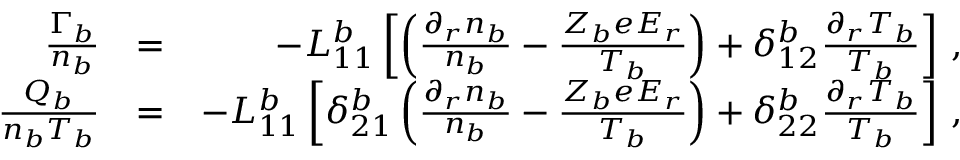<formula> <loc_0><loc_0><loc_500><loc_500>\begin{array} { r l r } { \frac { \Gamma _ { b } } { n _ { b } } } & { = } & { - L _ { 1 1 } ^ { b } \left [ \left ( \frac { \partial _ { r } n _ { b } } { n _ { b } } - \frac { Z _ { b } e E _ { r } } { T _ { b } } \right ) + \delta _ { 1 2 } ^ { b } \frac { \partial _ { r } T _ { b } } { T _ { b } } \right ] \, , } \\ { \frac { Q _ { b } } { n _ { b } T _ { b } } } & { = } & { - L _ { 1 1 } ^ { b } \left [ \delta _ { 2 1 } ^ { b } \left ( \frac { \partial _ { r } n _ { b } } { n _ { b } } - \frac { Z _ { b } e E _ { r } } { T _ { b } } \right ) + \delta _ { 2 2 } ^ { b } \frac { \partial _ { r } T _ { b } } { T _ { b } } \right ] \, , } \end{array}</formula> 